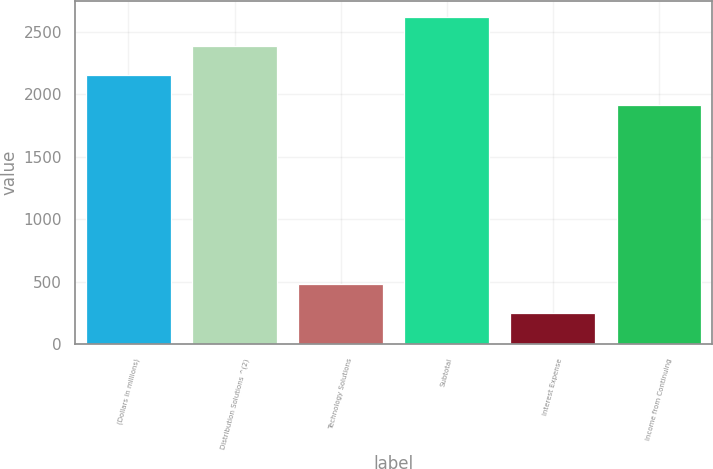<chart> <loc_0><loc_0><loc_500><loc_500><bar_chart><fcel>(Dollars in millions)<fcel>Distribution Solutions ^(2)<fcel>Technology Solutions<fcel>Subtotal<fcel>Interest Expense<fcel>Income from Continuing<nl><fcel>2152.2<fcel>2385.4<fcel>484.2<fcel>2618.6<fcel>251<fcel>1919<nl></chart> 